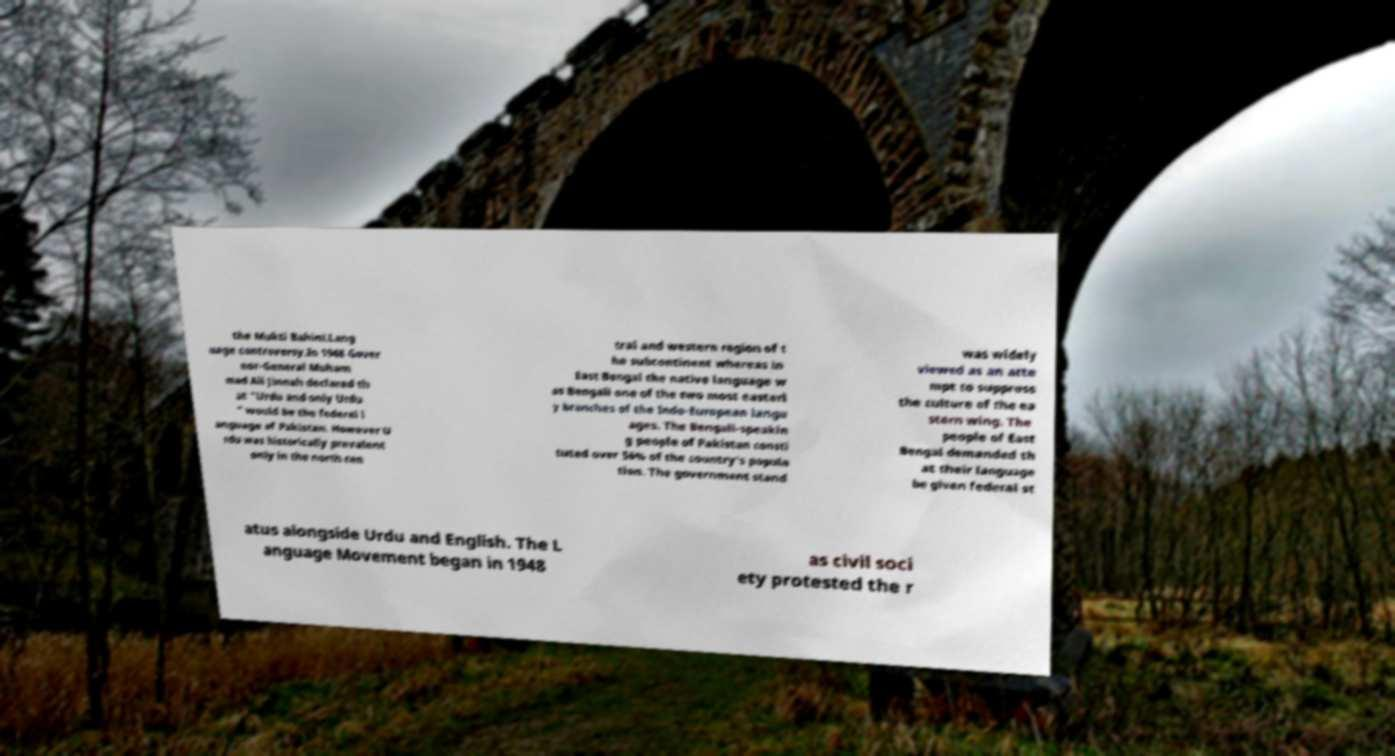Can you read and provide the text displayed in the image?This photo seems to have some interesting text. Can you extract and type it out for me? the Mukti Bahini.Lang uage controversy.In 1948 Gover nor-General Muham mad Ali Jinnah declared th at "Urdu and only Urdu " would be the federal l anguage of Pakistan. However U rdu was historically prevalent only in the north cen tral and western region of t he subcontinent whereas in East Bengal the native language w as Bengali one of the two most easterl y branches of the Indo-European langu ages. The Bengali-speakin g people of Pakistan consti tuted over 56% of the country's popula tion. The government stand was widely viewed as an atte mpt to suppress the culture of the ea stern wing. The people of East Bengal demanded th at their language be given federal st atus alongside Urdu and English. The L anguage Movement began in 1948 as civil soci ety protested the r 